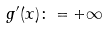<formula> <loc_0><loc_0><loc_500><loc_500>g ^ { \prime } ( x ) \colon = + \infty</formula> 